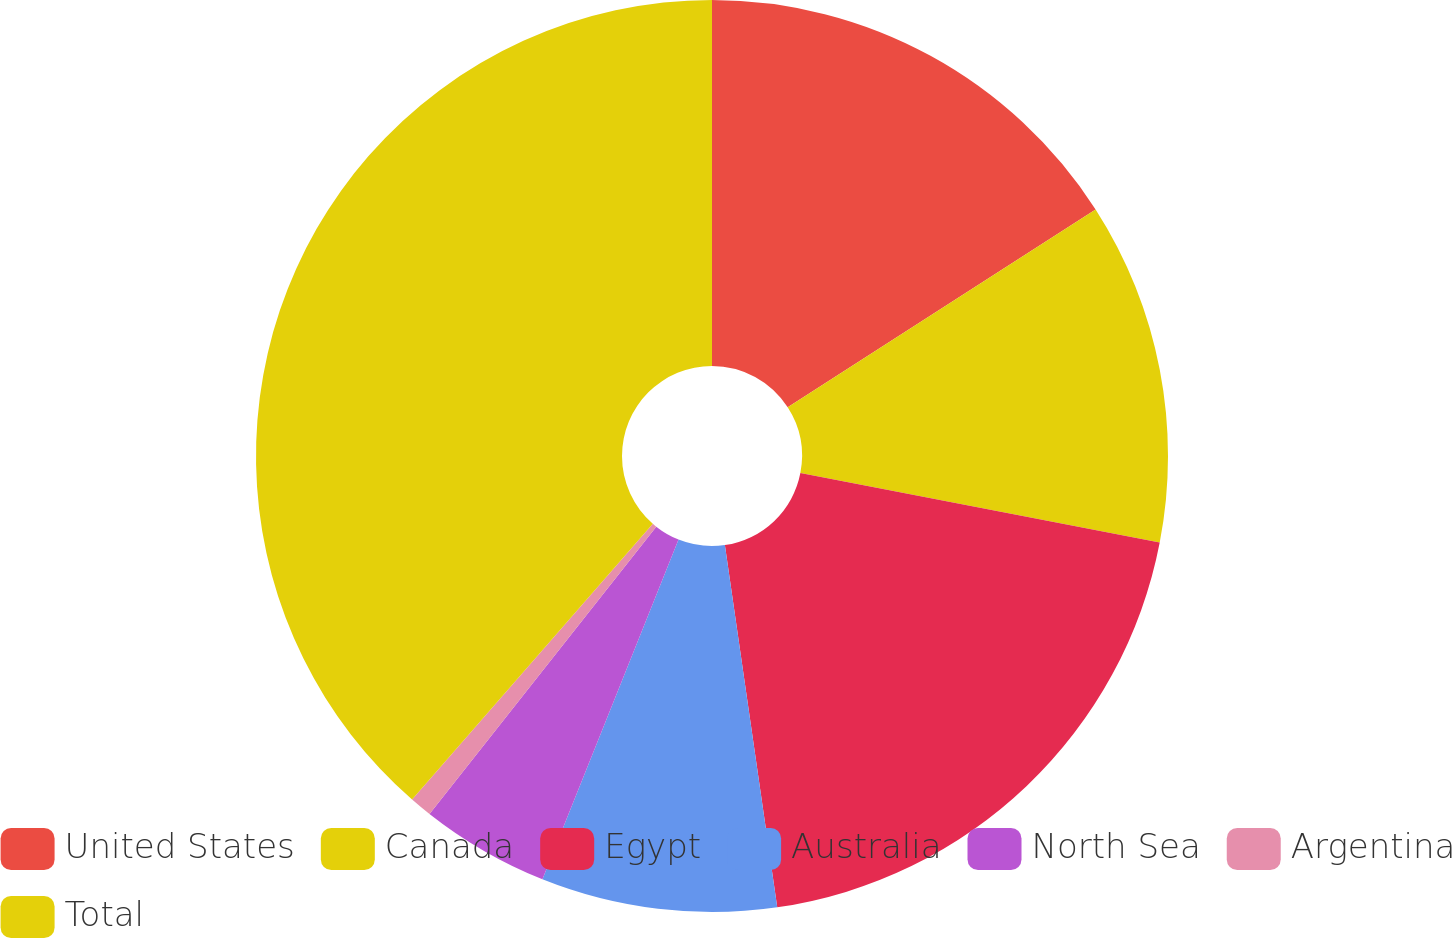Convert chart to OTSL. <chart><loc_0><loc_0><loc_500><loc_500><pie_chart><fcel>United States<fcel>Canada<fcel>Egypt<fcel>Australia<fcel>North Sea<fcel>Argentina<fcel>Total<nl><fcel>15.91%<fcel>12.13%<fcel>19.68%<fcel>8.35%<fcel>4.57%<fcel>0.79%<fcel>38.58%<nl></chart> 